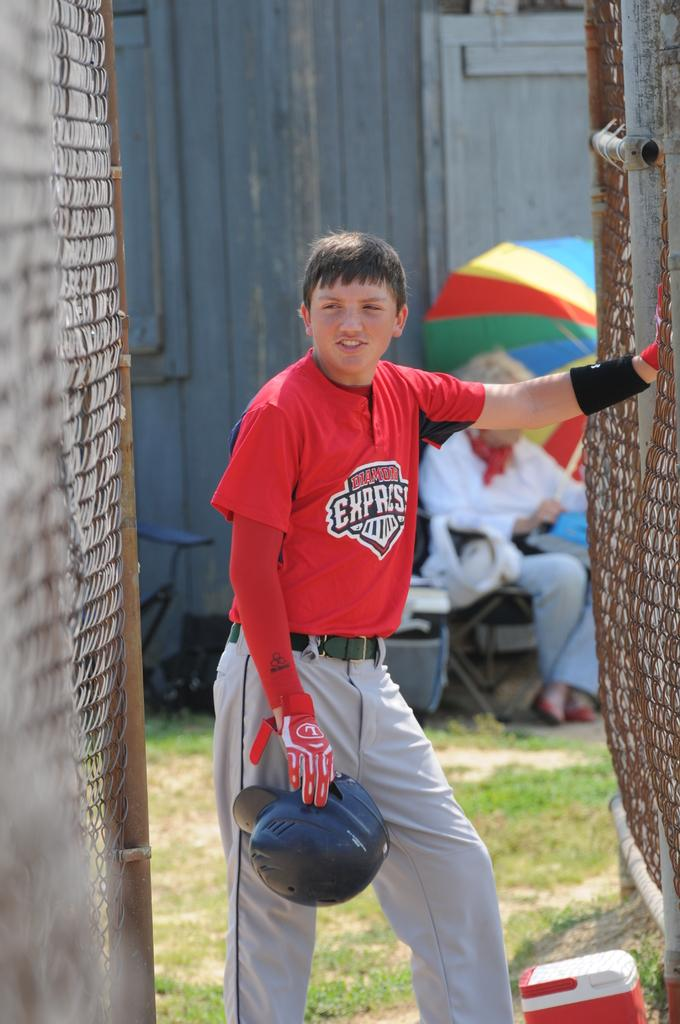<image>
Provide a brief description of the given image. A baseball player wearing a shirt that says Diamond Express 